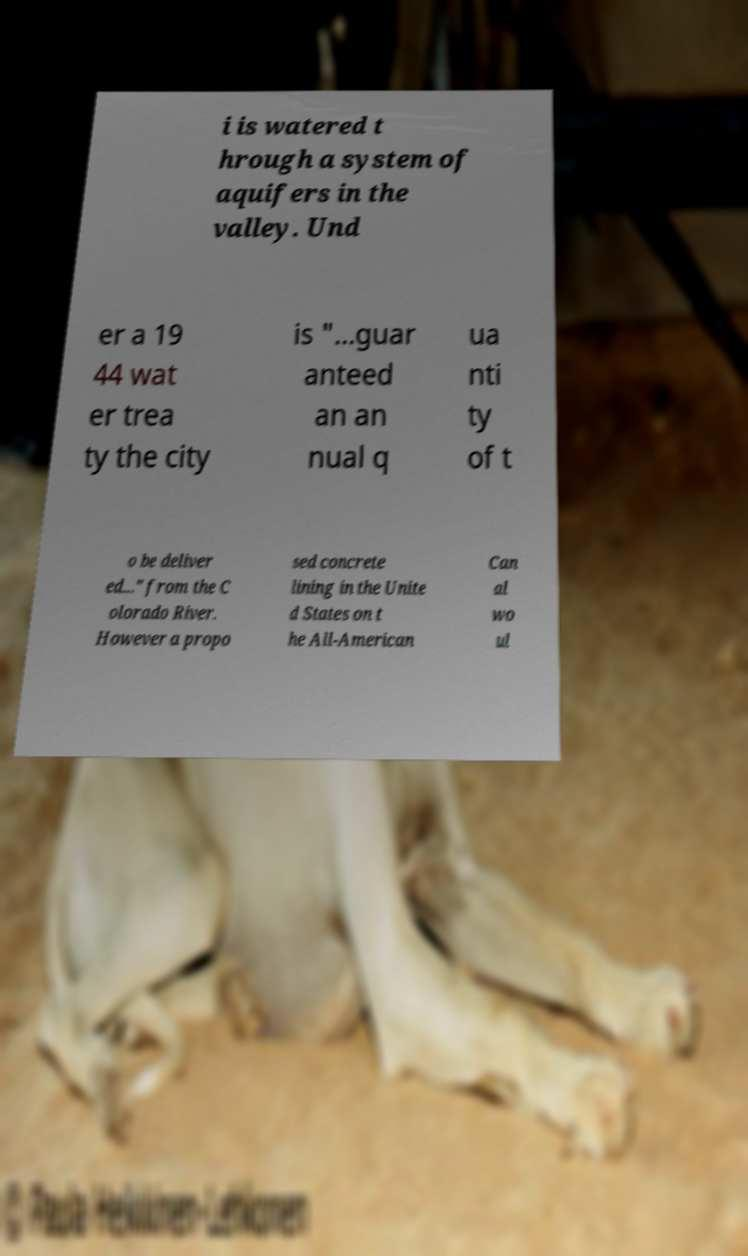I need the written content from this picture converted into text. Can you do that? i is watered t hrough a system of aquifers in the valley. Und er a 19 44 wat er trea ty the city is "...guar anteed an an nual q ua nti ty of t o be deliver ed..." from the C olorado River. However a propo sed concrete lining in the Unite d States on t he All-American Can al wo ul 